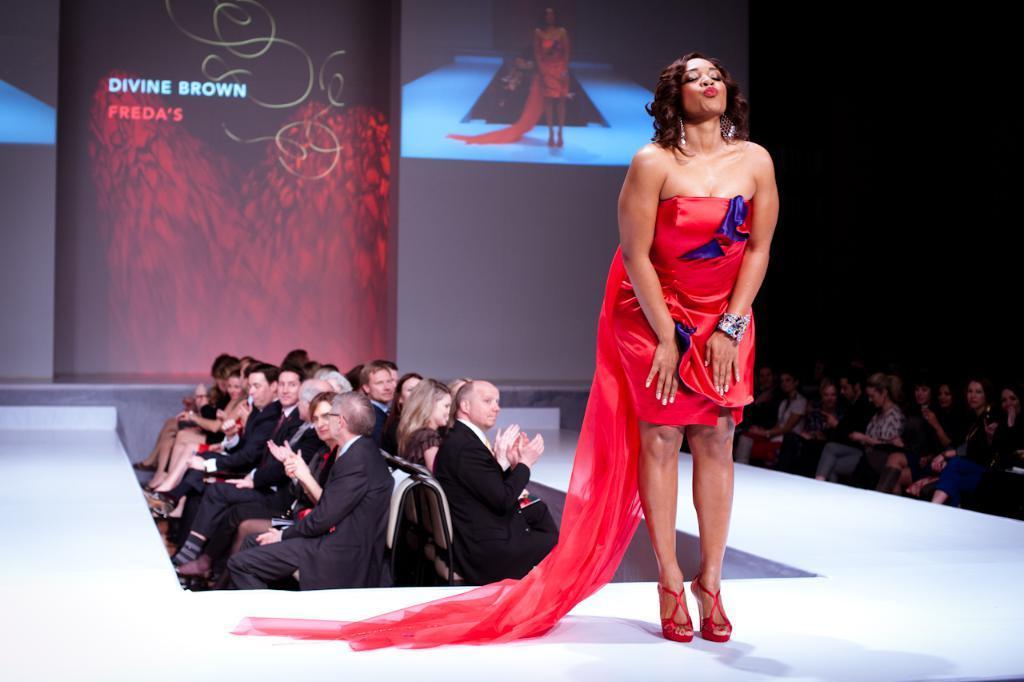Could you give a brief overview of what you see in this image? In this image I see the white platform on which there is a woman who is wearing red dress and I see number of people who are sitting on chairs. In the background I see the screen and I see something is written over here. 